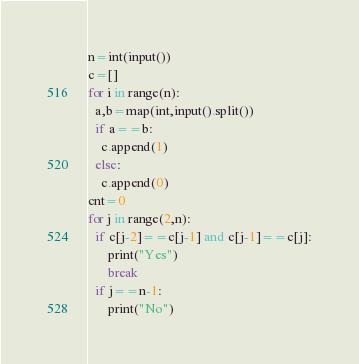<code> <loc_0><loc_0><loc_500><loc_500><_Python_>n=int(input())
c=[]
for i in range(n):
  a,b=map(int,input().split())
  if a==b:
    c.append(1)
  else:
    c.append(0)
cnt=0
for j in range(2,n):
  if c[j-2]==c[j-1] and c[j-1]==c[j]:
      print("Yes")
      break
  if j==n-1:
      print("No")</code> 